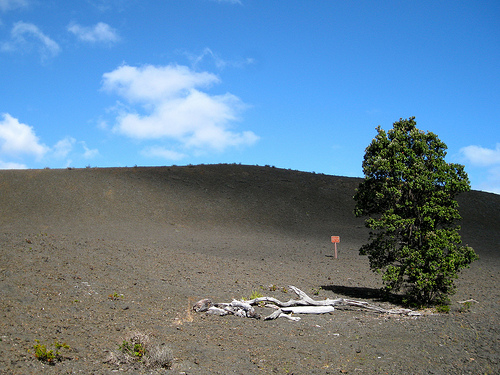<image>
Is the sign under the tree? No. The sign is not positioned under the tree. The vertical relationship between these objects is different. Is there a sky behind the land? Yes. From this viewpoint, the sky is positioned behind the land, with the land partially or fully occluding the sky. 